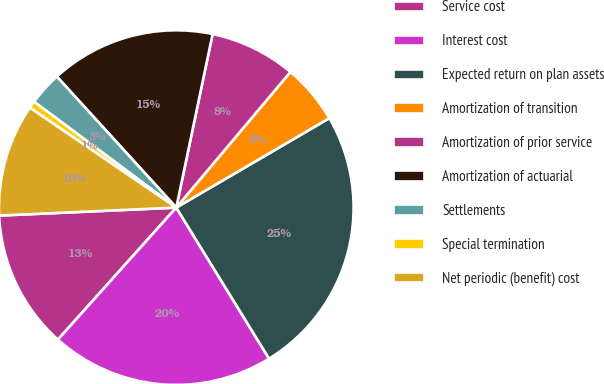<chart> <loc_0><loc_0><loc_500><loc_500><pie_chart><fcel>Service cost<fcel>Interest cost<fcel>Expected return on plan assets<fcel>Amortization of transition<fcel>Amortization of prior service<fcel>Amortization of actuarial<fcel>Settlements<fcel>Special termination<fcel>Net periodic (benefit) cost<nl><fcel>12.65%<fcel>20.4%<fcel>24.65%<fcel>5.45%<fcel>7.85%<fcel>15.05%<fcel>3.05%<fcel>0.65%<fcel>10.25%<nl></chart> 